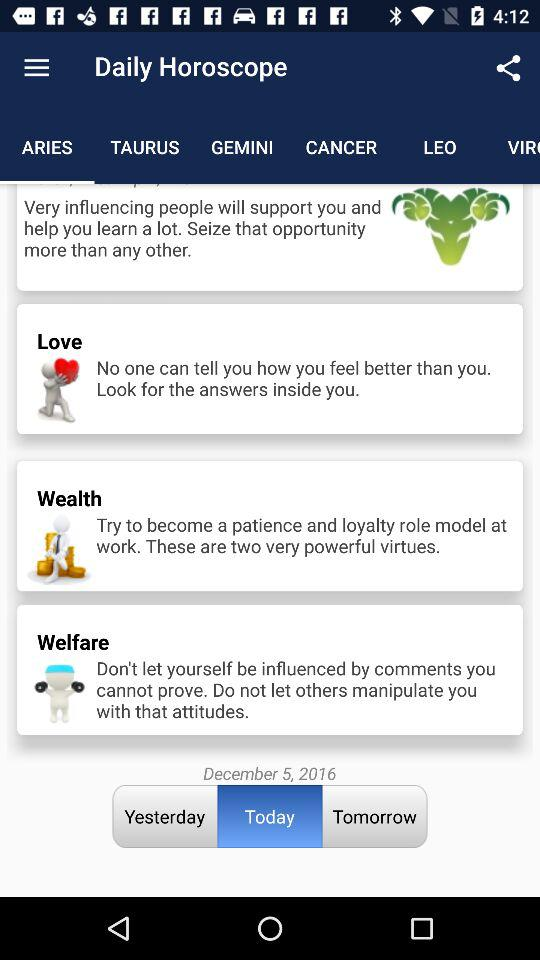What is the horoscope date? The date is December 5, 2016. 